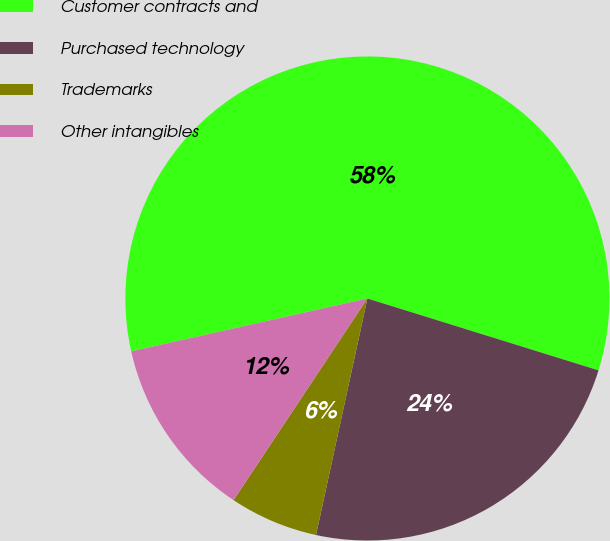Convert chart to OTSL. <chart><loc_0><loc_0><loc_500><loc_500><pie_chart><fcel>Customer contracts and<fcel>Purchased technology<fcel>Trademarks<fcel>Other intangibles<nl><fcel>58.31%<fcel>23.61%<fcel>5.92%<fcel>12.17%<nl></chart> 